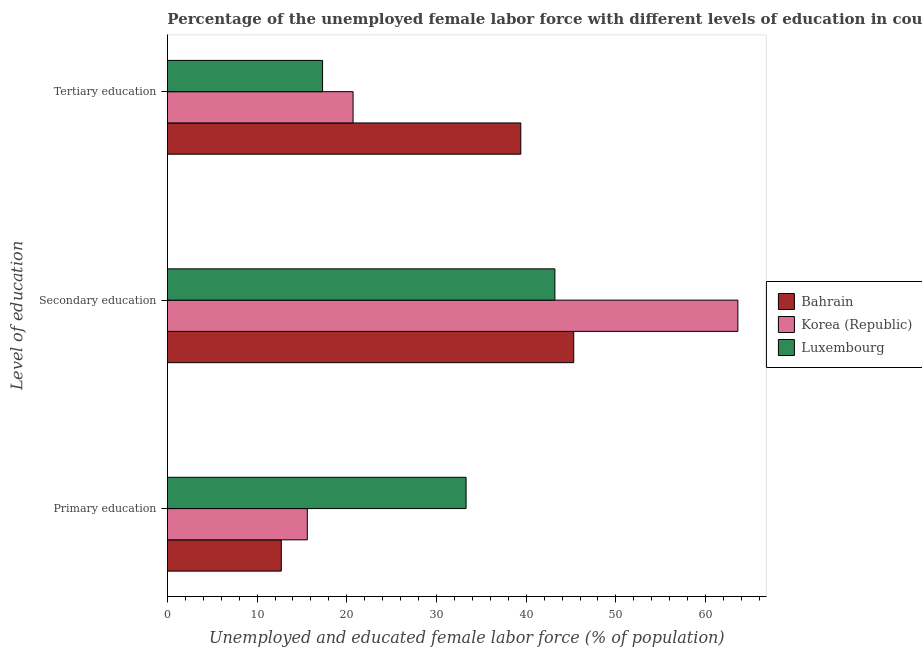How many bars are there on the 3rd tick from the top?
Keep it short and to the point. 3. How many bars are there on the 1st tick from the bottom?
Provide a short and direct response. 3. What is the label of the 1st group of bars from the top?
Your response must be concise. Tertiary education. What is the percentage of female labor force who received secondary education in Korea (Republic)?
Your answer should be compact. 63.6. Across all countries, what is the maximum percentage of female labor force who received secondary education?
Give a very brief answer. 63.6. Across all countries, what is the minimum percentage of female labor force who received primary education?
Make the answer very short. 12.7. In which country was the percentage of female labor force who received tertiary education maximum?
Offer a very short reply. Bahrain. In which country was the percentage of female labor force who received tertiary education minimum?
Give a very brief answer. Luxembourg. What is the total percentage of female labor force who received secondary education in the graph?
Give a very brief answer. 152.1. What is the difference between the percentage of female labor force who received secondary education in Luxembourg and that in Bahrain?
Your response must be concise. -2.1. What is the difference between the percentage of female labor force who received secondary education in Bahrain and the percentage of female labor force who received tertiary education in Luxembourg?
Give a very brief answer. 28. What is the average percentage of female labor force who received secondary education per country?
Keep it short and to the point. 50.7. What is the difference between the percentage of female labor force who received tertiary education and percentage of female labor force who received secondary education in Bahrain?
Offer a terse response. -5.9. What is the ratio of the percentage of female labor force who received primary education in Bahrain to that in Luxembourg?
Give a very brief answer. 0.38. Is the percentage of female labor force who received tertiary education in Korea (Republic) less than that in Luxembourg?
Your answer should be very brief. No. Is the difference between the percentage of female labor force who received tertiary education in Korea (Republic) and Luxembourg greater than the difference between the percentage of female labor force who received primary education in Korea (Republic) and Luxembourg?
Your answer should be compact. Yes. What is the difference between the highest and the second highest percentage of female labor force who received tertiary education?
Your answer should be compact. 18.7. What is the difference between the highest and the lowest percentage of female labor force who received primary education?
Your response must be concise. 20.6. In how many countries, is the percentage of female labor force who received primary education greater than the average percentage of female labor force who received primary education taken over all countries?
Provide a succinct answer. 1. What does the 1st bar from the top in Primary education represents?
Provide a succinct answer. Luxembourg. What does the 3rd bar from the bottom in Tertiary education represents?
Offer a very short reply. Luxembourg. Is it the case that in every country, the sum of the percentage of female labor force who received primary education and percentage of female labor force who received secondary education is greater than the percentage of female labor force who received tertiary education?
Your response must be concise. Yes. How many bars are there?
Ensure brevity in your answer.  9. Are all the bars in the graph horizontal?
Make the answer very short. Yes. How are the legend labels stacked?
Make the answer very short. Vertical. What is the title of the graph?
Your response must be concise. Percentage of the unemployed female labor force with different levels of education in countries. What is the label or title of the X-axis?
Offer a terse response. Unemployed and educated female labor force (% of population). What is the label or title of the Y-axis?
Keep it short and to the point. Level of education. What is the Unemployed and educated female labor force (% of population) of Bahrain in Primary education?
Ensure brevity in your answer.  12.7. What is the Unemployed and educated female labor force (% of population) of Korea (Republic) in Primary education?
Provide a short and direct response. 15.6. What is the Unemployed and educated female labor force (% of population) in Luxembourg in Primary education?
Make the answer very short. 33.3. What is the Unemployed and educated female labor force (% of population) of Bahrain in Secondary education?
Provide a succinct answer. 45.3. What is the Unemployed and educated female labor force (% of population) in Korea (Republic) in Secondary education?
Offer a terse response. 63.6. What is the Unemployed and educated female labor force (% of population) of Luxembourg in Secondary education?
Ensure brevity in your answer.  43.2. What is the Unemployed and educated female labor force (% of population) in Bahrain in Tertiary education?
Provide a short and direct response. 39.4. What is the Unemployed and educated female labor force (% of population) in Korea (Republic) in Tertiary education?
Your response must be concise. 20.7. What is the Unemployed and educated female labor force (% of population) of Luxembourg in Tertiary education?
Your response must be concise. 17.3. Across all Level of education, what is the maximum Unemployed and educated female labor force (% of population) in Bahrain?
Offer a very short reply. 45.3. Across all Level of education, what is the maximum Unemployed and educated female labor force (% of population) of Korea (Republic)?
Provide a succinct answer. 63.6. Across all Level of education, what is the maximum Unemployed and educated female labor force (% of population) in Luxembourg?
Your answer should be compact. 43.2. Across all Level of education, what is the minimum Unemployed and educated female labor force (% of population) in Bahrain?
Ensure brevity in your answer.  12.7. Across all Level of education, what is the minimum Unemployed and educated female labor force (% of population) in Korea (Republic)?
Provide a succinct answer. 15.6. Across all Level of education, what is the minimum Unemployed and educated female labor force (% of population) of Luxembourg?
Provide a succinct answer. 17.3. What is the total Unemployed and educated female labor force (% of population) in Bahrain in the graph?
Your response must be concise. 97.4. What is the total Unemployed and educated female labor force (% of population) in Korea (Republic) in the graph?
Give a very brief answer. 99.9. What is the total Unemployed and educated female labor force (% of population) in Luxembourg in the graph?
Your response must be concise. 93.8. What is the difference between the Unemployed and educated female labor force (% of population) in Bahrain in Primary education and that in Secondary education?
Make the answer very short. -32.6. What is the difference between the Unemployed and educated female labor force (% of population) of Korea (Republic) in Primary education and that in Secondary education?
Provide a short and direct response. -48. What is the difference between the Unemployed and educated female labor force (% of population) of Bahrain in Primary education and that in Tertiary education?
Ensure brevity in your answer.  -26.7. What is the difference between the Unemployed and educated female labor force (% of population) in Korea (Republic) in Primary education and that in Tertiary education?
Give a very brief answer. -5.1. What is the difference between the Unemployed and educated female labor force (% of population) in Bahrain in Secondary education and that in Tertiary education?
Keep it short and to the point. 5.9. What is the difference between the Unemployed and educated female labor force (% of population) in Korea (Republic) in Secondary education and that in Tertiary education?
Your response must be concise. 42.9. What is the difference between the Unemployed and educated female labor force (% of population) of Luxembourg in Secondary education and that in Tertiary education?
Offer a terse response. 25.9. What is the difference between the Unemployed and educated female labor force (% of population) of Bahrain in Primary education and the Unemployed and educated female labor force (% of population) of Korea (Republic) in Secondary education?
Your response must be concise. -50.9. What is the difference between the Unemployed and educated female labor force (% of population) of Bahrain in Primary education and the Unemployed and educated female labor force (% of population) of Luxembourg in Secondary education?
Ensure brevity in your answer.  -30.5. What is the difference between the Unemployed and educated female labor force (% of population) in Korea (Republic) in Primary education and the Unemployed and educated female labor force (% of population) in Luxembourg in Secondary education?
Your answer should be compact. -27.6. What is the difference between the Unemployed and educated female labor force (% of population) of Bahrain in Primary education and the Unemployed and educated female labor force (% of population) of Korea (Republic) in Tertiary education?
Ensure brevity in your answer.  -8. What is the difference between the Unemployed and educated female labor force (% of population) of Bahrain in Secondary education and the Unemployed and educated female labor force (% of population) of Korea (Republic) in Tertiary education?
Your answer should be very brief. 24.6. What is the difference between the Unemployed and educated female labor force (% of population) in Korea (Republic) in Secondary education and the Unemployed and educated female labor force (% of population) in Luxembourg in Tertiary education?
Keep it short and to the point. 46.3. What is the average Unemployed and educated female labor force (% of population) in Bahrain per Level of education?
Offer a very short reply. 32.47. What is the average Unemployed and educated female labor force (% of population) in Korea (Republic) per Level of education?
Offer a terse response. 33.3. What is the average Unemployed and educated female labor force (% of population) in Luxembourg per Level of education?
Provide a succinct answer. 31.27. What is the difference between the Unemployed and educated female labor force (% of population) in Bahrain and Unemployed and educated female labor force (% of population) in Luxembourg in Primary education?
Provide a short and direct response. -20.6. What is the difference between the Unemployed and educated female labor force (% of population) of Korea (Republic) and Unemployed and educated female labor force (% of population) of Luxembourg in Primary education?
Your response must be concise. -17.7. What is the difference between the Unemployed and educated female labor force (% of population) in Bahrain and Unemployed and educated female labor force (% of population) in Korea (Republic) in Secondary education?
Keep it short and to the point. -18.3. What is the difference between the Unemployed and educated female labor force (% of population) in Bahrain and Unemployed and educated female labor force (% of population) in Luxembourg in Secondary education?
Give a very brief answer. 2.1. What is the difference between the Unemployed and educated female labor force (% of population) in Korea (Republic) and Unemployed and educated female labor force (% of population) in Luxembourg in Secondary education?
Give a very brief answer. 20.4. What is the difference between the Unemployed and educated female labor force (% of population) of Bahrain and Unemployed and educated female labor force (% of population) of Luxembourg in Tertiary education?
Make the answer very short. 22.1. What is the ratio of the Unemployed and educated female labor force (% of population) of Bahrain in Primary education to that in Secondary education?
Provide a short and direct response. 0.28. What is the ratio of the Unemployed and educated female labor force (% of population) in Korea (Republic) in Primary education to that in Secondary education?
Your response must be concise. 0.25. What is the ratio of the Unemployed and educated female labor force (% of population) in Luxembourg in Primary education to that in Secondary education?
Offer a terse response. 0.77. What is the ratio of the Unemployed and educated female labor force (% of population) of Bahrain in Primary education to that in Tertiary education?
Provide a succinct answer. 0.32. What is the ratio of the Unemployed and educated female labor force (% of population) of Korea (Republic) in Primary education to that in Tertiary education?
Keep it short and to the point. 0.75. What is the ratio of the Unemployed and educated female labor force (% of population) in Luxembourg in Primary education to that in Tertiary education?
Give a very brief answer. 1.92. What is the ratio of the Unemployed and educated female labor force (% of population) in Bahrain in Secondary education to that in Tertiary education?
Your answer should be compact. 1.15. What is the ratio of the Unemployed and educated female labor force (% of population) in Korea (Republic) in Secondary education to that in Tertiary education?
Your answer should be compact. 3.07. What is the ratio of the Unemployed and educated female labor force (% of population) in Luxembourg in Secondary education to that in Tertiary education?
Keep it short and to the point. 2.5. What is the difference between the highest and the second highest Unemployed and educated female labor force (% of population) in Bahrain?
Provide a succinct answer. 5.9. What is the difference between the highest and the second highest Unemployed and educated female labor force (% of population) of Korea (Republic)?
Ensure brevity in your answer.  42.9. What is the difference between the highest and the lowest Unemployed and educated female labor force (% of population) in Bahrain?
Keep it short and to the point. 32.6. What is the difference between the highest and the lowest Unemployed and educated female labor force (% of population) of Korea (Republic)?
Give a very brief answer. 48. What is the difference between the highest and the lowest Unemployed and educated female labor force (% of population) in Luxembourg?
Your answer should be compact. 25.9. 